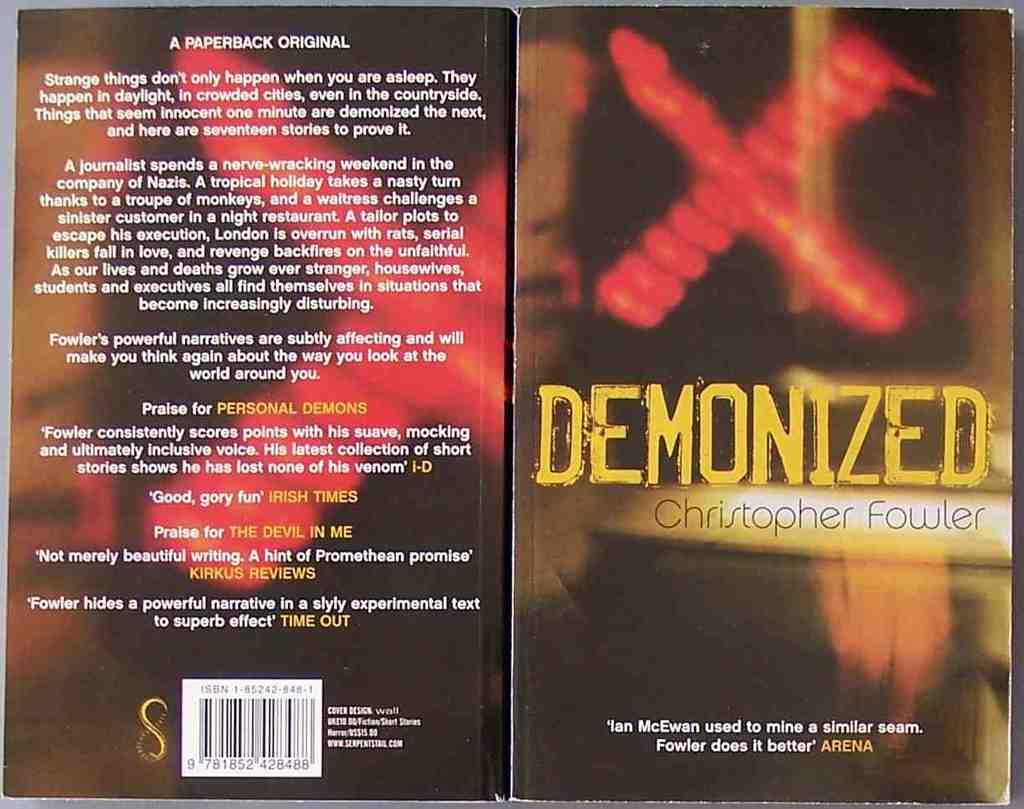What is the title of the book?
Your answer should be compact. Demonized. 